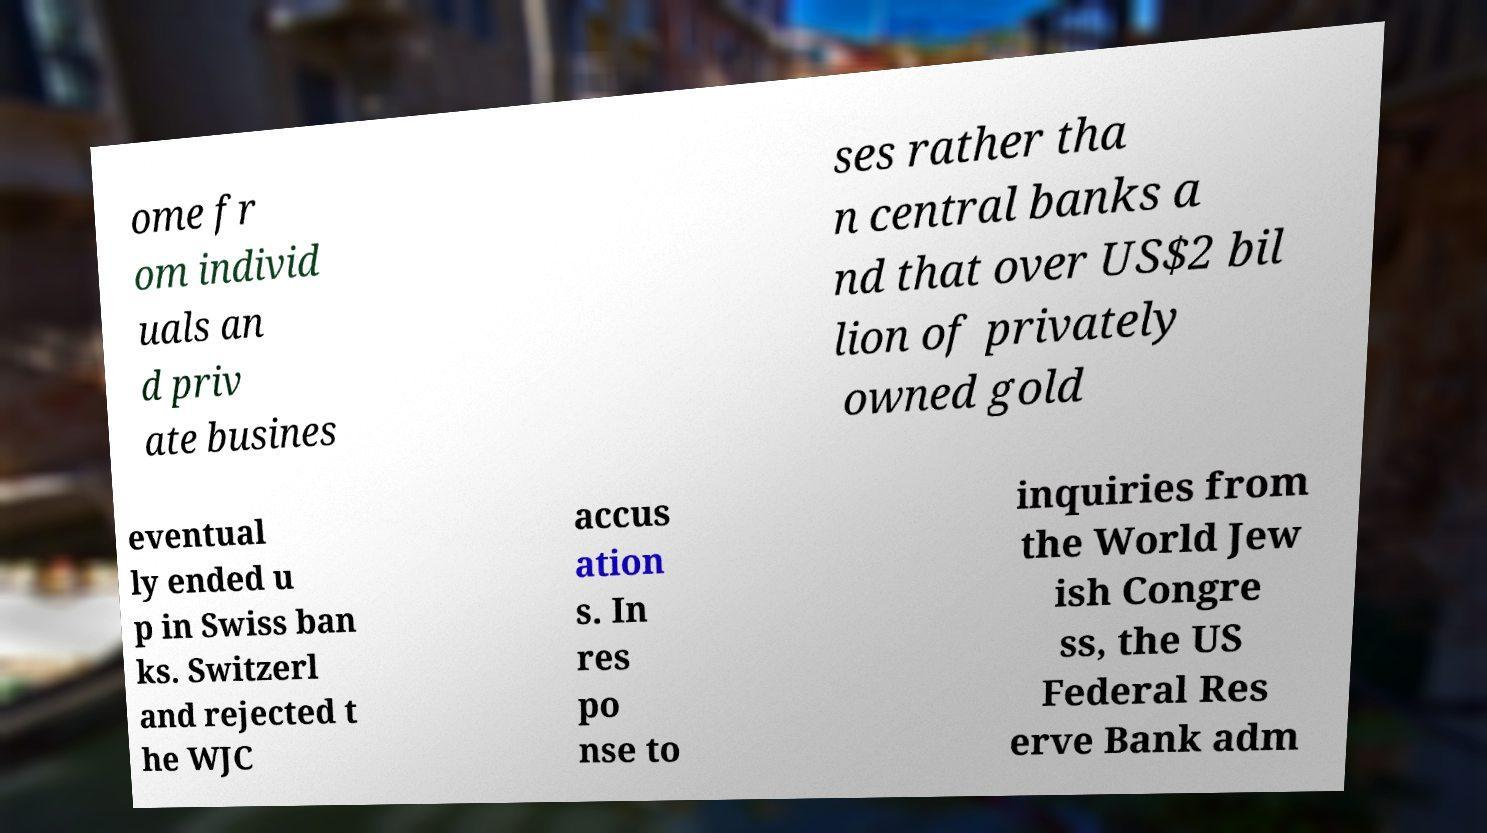There's text embedded in this image that I need extracted. Can you transcribe it verbatim? ome fr om individ uals an d priv ate busines ses rather tha n central banks a nd that over US$2 bil lion of privately owned gold eventual ly ended u p in Swiss ban ks. Switzerl and rejected t he WJC accus ation s. In res po nse to inquiries from the World Jew ish Congre ss, the US Federal Res erve Bank adm 